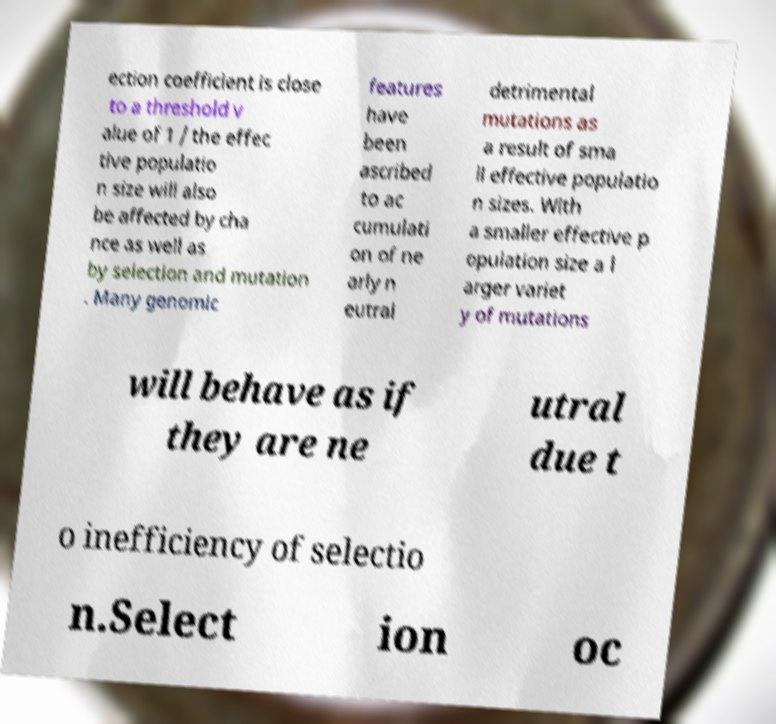Could you extract and type out the text from this image? ection coefficient is close to a threshold v alue of 1 / the effec tive populatio n size will also be affected by cha nce as well as by selection and mutation . Many genomic features have been ascribed to ac cumulati on of ne arly n eutral detrimental mutations as a result of sma ll effective populatio n sizes. With a smaller effective p opulation size a l arger variet y of mutations will behave as if they are ne utral due t o inefficiency of selectio n.Select ion oc 